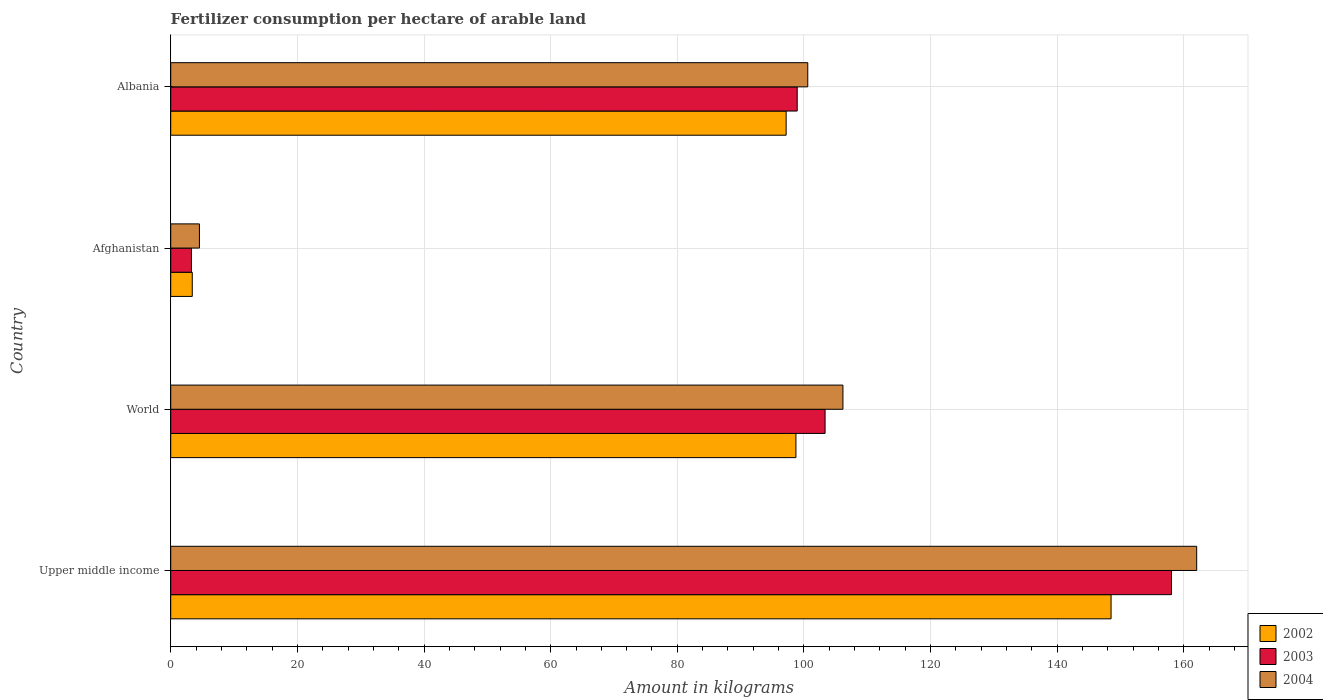How many different coloured bars are there?
Keep it short and to the point. 3. How many groups of bars are there?
Provide a short and direct response. 4. Are the number of bars per tick equal to the number of legend labels?
Offer a very short reply. Yes. How many bars are there on the 4th tick from the bottom?
Offer a terse response. 3. What is the label of the 2nd group of bars from the top?
Keep it short and to the point. Afghanistan. In how many cases, is the number of bars for a given country not equal to the number of legend labels?
Your response must be concise. 0. What is the amount of fertilizer consumption in 2004 in World?
Offer a very short reply. 106.15. Across all countries, what is the maximum amount of fertilizer consumption in 2002?
Offer a very short reply. 148.49. Across all countries, what is the minimum amount of fertilizer consumption in 2004?
Provide a short and direct response. 4.54. In which country was the amount of fertilizer consumption in 2004 maximum?
Ensure brevity in your answer.  Upper middle income. In which country was the amount of fertilizer consumption in 2002 minimum?
Give a very brief answer. Afghanistan. What is the total amount of fertilizer consumption in 2004 in the graph?
Provide a succinct answer. 373.31. What is the difference between the amount of fertilizer consumption in 2004 in Afghanistan and that in World?
Provide a succinct answer. -101.62. What is the difference between the amount of fertilizer consumption in 2004 in Albania and the amount of fertilizer consumption in 2002 in Afghanistan?
Give a very brief answer. 97.2. What is the average amount of fertilizer consumption in 2004 per country?
Make the answer very short. 93.33. What is the difference between the amount of fertilizer consumption in 2004 and amount of fertilizer consumption in 2003 in Albania?
Make the answer very short. 1.67. In how many countries, is the amount of fertilizer consumption in 2002 greater than 12 kg?
Make the answer very short. 3. What is the ratio of the amount of fertilizer consumption in 2004 in Albania to that in Upper middle income?
Your response must be concise. 0.62. What is the difference between the highest and the second highest amount of fertilizer consumption in 2004?
Keep it short and to the point. 55.86. What is the difference between the highest and the lowest amount of fertilizer consumption in 2002?
Your response must be concise. 145.09. What does the 1st bar from the top in Albania represents?
Keep it short and to the point. 2004. What does the 1st bar from the bottom in Afghanistan represents?
Give a very brief answer. 2002. Are the values on the major ticks of X-axis written in scientific E-notation?
Your response must be concise. No. Does the graph contain grids?
Make the answer very short. Yes. Where does the legend appear in the graph?
Offer a very short reply. Bottom right. How are the legend labels stacked?
Make the answer very short. Vertical. What is the title of the graph?
Your response must be concise. Fertilizer consumption per hectare of arable land. What is the label or title of the X-axis?
Provide a succinct answer. Amount in kilograms. What is the Amount in kilograms in 2002 in Upper middle income?
Ensure brevity in your answer.  148.49. What is the Amount in kilograms in 2003 in Upper middle income?
Offer a terse response. 158.03. What is the Amount in kilograms in 2004 in Upper middle income?
Ensure brevity in your answer.  162.02. What is the Amount in kilograms of 2002 in World?
Offer a very short reply. 98.73. What is the Amount in kilograms of 2003 in World?
Ensure brevity in your answer.  103.33. What is the Amount in kilograms of 2004 in World?
Offer a terse response. 106.15. What is the Amount in kilograms of 2002 in Afghanistan?
Offer a very short reply. 3.4. What is the Amount in kilograms of 2003 in Afghanistan?
Make the answer very short. 3.28. What is the Amount in kilograms of 2004 in Afghanistan?
Offer a very short reply. 4.54. What is the Amount in kilograms of 2002 in Albania?
Provide a short and direct response. 97.19. What is the Amount in kilograms of 2003 in Albania?
Offer a terse response. 98.93. What is the Amount in kilograms in 2004 in Albania?
Your answer should be very brief. 100.6. Across all countries, what is the maximum Amount in kilograms of 2002?
Your answer should be compact. 148.49. Across all countries, what is the maximum Amount in kilograms in 2003?
Offer a very short reply. 158.03. Across all countries, what is the maximum Amount in kilograms of 2004?
Give a very brief answer. 162.02. Across all countries, what is the minimum Amount in kilograms of 2002?
Give a very brief answer. 3.4. Across all countries, what is the minimum Amount in kilograms of 2003?
Ensure brevity in your answer.  3.28. Across all countries, what is the minimum Amount in kilograms of 2004?
Give a very brief answer. 4.54. What is the total Amount in kilograms in 2002 in the graph?
Your answer should be compact. 347.81. What is the total Amount in kilograms in 2003 in the graph?
Make the answer very short. 363.58. What is the total Amount in kilograms in 2004 in the graph?
Make the answer very short. 373.31. What is the difference between the Amount in kilograms in 2002 in Upper middle income and that in World?
Your response must be concise. 49.76. What is the difference between the Amount in kilograms of 2003 in Upper middle income and that in World?
Give a very brief answer. 54.7. What is the difference between the Amount in kilograms in 2004 in Upper middle income and that in World?
Make the answer very short. 55.86. What is the difference between the Amount in kilograms in 2002 in Upper middle income and that in Afghanistan?
Keep it short and to the point. 145.09. What is the difference between the Amount in kilograms of 2003 in Upper middle income and that in Afghanistan?
Ensure brevity in your answer.  154.76. What is the difference between the Amount in kilograms of 2004 in Upper middle income and that in Afghanistan?
Make the answer very short. 157.48. What is the difference between the Amount in kilograms in 2002 in Upper middle income and that in Albania?
Your answer should be compact. 51.31. What is the difference between the Amount in kilograms of 2003 in Upper middle income and that in Albania?
Make the answer very short. 59.1. What is the difference between the Amount in kilograms in 2004 in Upper middle income and that in Albania?
Provide a short and direct response. 61.42. What is the difference between the Amount in kilograms of 2002 in World and that in Afghanistan?
Ensure brevity in your answer.  95.33. What is the difference between the Amount in kilograms of 2003 in World and that in Afghanistan?
Provide a succinct answer. 100.06. What is the difference between the Amount in kilograms of 2004 in World and that in Afghanistan?
Offer a terse response. 101.62. What is the difference between the Amount in kilograms in 2002 in World and that in Albania?
Your response must be concise. 1.55. What is the difference between the Amount in kilograms of 2003 in World and that in Albania?
Keep it short and to the point. 4.4. What is the difference between the Amount in kilograms of 2004 in World and that in Albania?
Give a very brief answer. 5.56. What is the difference between the Amount in kilograms in 2002 in Afghanistan and that in Albania?
Offer a very short reply. -93.78. What is the difference between the Amount in kilograms in 2003 in Afghanistan and that in Albania?
Provide a succinct answer. -95.66. What is the difference between the Amount in kilograms in 2004 in Afghanistan and that in Albania?
Your response must be concise. -96.06. What is the difference between the Amount in kilograms of 2002 in Upper middle income and the Amount in kilograms of 2003 in World?
Provide a short and direct response. 45.16. What is the difference between the Amount in kilograms in 2002 in Upper middle income and the Amount in kilograms in 2004 in World?
Provide a succinct answer. 42.34. What is the difference between the Amount in kilograms in 2003 in Upper middle income and the Amount in kilograms in 2004 in World?
Make the answer very short. 51.88. What is the difference between the Amount in kilograms of 2002 in Upper middle income and the Amount in kilograms of 2003 in Afghanistan?
Your answer should be compact. 145.22. What is the difference between the Amount in kilograms of 2002 in Upper middle income and the Amount in kilograms of 2004 in Afghanistan?
Provide a succinct answer. 143.96. What is the difference between the Amount in kilograms of 2003 in Upper middle income and the Amount in kilograms of 2004 in Afghanistan?
Keep it short and to the point. 153.5. What is the difference between the Amount in kilograms of 2002 in Upper middle income and the Amount in kilograms of 2003 in Albania?
Offer a very short reply. 49.56. What is the difference between the Amount in kilograms of 2002 in Upper middle income and the Amount in kilograms of 2004 in Albania?
Make the answer very short. 47.9. What is the difference between the Amount in kilograms of 2003 in Upper middle income and the Amount in kilograms of 2004 in Albania?
Provide a short and direct response. 57.44. What is the difference between the Amount in kilograms in 2002 in World and the Amount in kilograms in 2003 in Afghanistan?
Offer a terse response. 95.46. What is the difference between the Amount in kilograms of 2002 in World and the Amount in kilograms of 2004 in Afghanistan?
Give a very brief answer. 94.2. What is the difference between the Amount in kilograms of 2003 in World and the Amount in kilograms of 2004 in Afghanistan?
Give a very brief answer. 98.8. What is the difference between the Amount in kilograms in 2002 in World and the Amount in kilograms in 2003 in Albania?
Provide a succinct answer. -0.2. What is the difference between the Amount in kilograms in 2002 in World and the Amount in kilograms in 2004 in Albania?
Your answer should be compact. -1.87. What is the difference between the Amount in kilograms in 2003 in World and the Amount in kilograms in 2004 in Albania?
Your response must be concise. 2.73. What is the difference between the Amount in kilograms in 2002 in Afghanistan and the Amount in kilograms in 2003 in Albania?
Offer a very short reply. -95.53. What is the difference between the Amount in kilograms in 2002 in Afghanistan and the Amount in kilograms in 2004 in Albania?
Make the answer very short. -97.2. What is the difference between the Amount in kilograms in 2003 in Afghanistan and the Amount in kilograms in 2004 in Albania?
Your response must be concise. -97.32. What is the average Amount in kilograms of 2002 per country?
Keep it short and to the point. 86.95. What is the average Amount in kilograms of 2003 per country?
Your response must be concise. 90.89. What is the average Amount in kilograms of 2004 per country?
Give a very brief answer. 93.33. What is the difference between the Amount in kilograms of 2002 and Amount in kilograms of 2003 in Upper middle income?
Offer a terse response. -9.54. What is the difference between the Amount in kilograms of 2002 and Amount in kilograms of 2004 in Upper middle income?
Your response must be concise. -13.52. What is the difference between the Amount in kilograms of 2003 and Amount in kilograms of 2004 in Upper middle income?
Give a very brief answer. -3.98. What is the difference between the Amount in kilograms of 2002 and Amount in kilograms of 2003 in World?
Your answer should be compact. -4.6. What is the difference between the Amount in kilograms in 2002 and Amount in kilograms in 2004 in World?
Provide a short and direct response. -7.42. What is the difference between the Amount in kilograms of 2003 and Amount in kilograms of 2004 in World?
Your answer should be very brief. -2.82. What is the difference between the Amount in kilograms of 2002 and Amount in kilograms of 2003 in Afghanistan?
Keep it short and to the point. 0.13. What is the difference between the Amount in kilograms in 2002 and Amount in kilograms in 2004 in Afghanistan?
Make the answer very short. -1.13. What is the difference between the Amount in kilograms of 2003 and Amount in kilograms of 2004 in Afghanistan?
Keep it short and to the point. -1.26. What is the difference between the Amount in kilograms of 2002 and Amount in kilograms of 2003 in Albania?
Your response must be concise. -1.75. What is the difference between the Amount in kilograms of 2002 and Amount in kilograms of 2004 in Albania?
Provide a succinct answer. -3.41. What is the difference between the Amount in kilograms in 2003 and Amount in kilograms in 2004 in Albania?
Provide a short and direct response. -1.67. What is the ratio of the Amount in kilograms in 2002 in Upper middle income to that in World?
Give a very brief answer. 1.5. What is the ratio of the Amount in kilograms of 2003 in Upper middle income to that in World?
Your answer should be compact. 1.53. What is the ratio of the Amount in kilograms of 2004 in Upper middle income to that in World?
Your response must be concise. 1.53. What is the ratio of the Amount in kilograms of 2002 in Upper middle income to that in Afghanistan?
Your answer should be very brief. 43.63. What is the ratio of the Amount in kilograms in 2003 in Upper middle income to that in Afghanistan?
Make the answer very short. 48.25. What is the ratio of the Amount in kilograms of 2004 in Upper middle income to that in Afghanistan?
Keep it short and to the point. 35.72. What is the ratio of the Amount in kilograms in 2002 in Upper middle income to that in Albania?
Offer a very short reply. 1.53. What is the ratio of the Amount in kilograms of 2003 in Upper middle income to that in Albania?
Provide a short and direct response. 1.6. What is the ratio of the Amount in kilograms in 2004 in Upper middle income to that in Albania?
Your answer should be compact. 1.61. What is the ratio of the Amount in kilograms in 2002 in World to that in Afghanistan?
Keep it short and to the point. 29.01. What is the ratio of the Amount in kilograms in 2003 in World to that in Afghanistan?
Ensure brevity in your answer.  31.55. What is the ratio of the Amount in kilograms of 2004 in World to that in Afghanistan?
Give a very brief answer. 23.4. What is the ratio of the Amount in kilograms of 2002 in World to that in Albania?
Offer a very short reply. 1.02. What is the ratio of the Amount in kilograms of 2003 in World to that in Albania?
Ensure brevity in your answer.  1.04. What is the ratio of the Amount in kilograms in 2004 in World to that in Albania?
Offer a terse response. 1.06. What is the ratio of the Amount in kilograms of 2002 in Afghanistan to that in Albania?
Offer a very short reply. 0.04. What is the ratio of the Amount in kilograms of 2003 in Afghanistan to that in Albania?
Offer a very short reply. 0.03. What is the ratio of the Amount in kilograms in 2004 in Afghanistan to that in Albania?
Your answer should be compact. 0.05. What is the difference between the highest and the second highest Amount in kilograms in 2002?
Your answer should be very brief. 49.76. What is the difference between the highest and the second highest Amount in kilograms in 2003?
Your answer should be very brief. 54.7. What is the difference between the highest and the second highest Amount in kilograms in 2004?
Give a very brief answer. 55.86. What is the difference between the highest and the lowest Amount in kilograms of 2002?
Provide a short and direct response. 145.09. What is the difference between the highest and the lowest Amount in kilograms in 2003?
Your answer should be compact. 154.76. What is the difference between the highest and the lowest Amount in kilograms in 2004?
Keep it short and to the point. 157.48. 